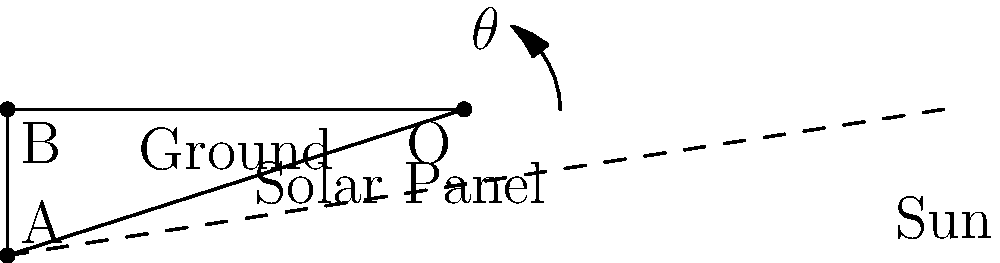In an emergency relief camp, you need to set up solar panels to power essential equipment. The angle of the sun above the horizon is 60°. At what angle $\theta$ should you tilt the solar panels from the ground to maximize energy collection? To maximize energy collection, we want the solar panels to be perpendicular to the incoming sunlight. This means we need to find the angle that makes the solar panel perpendicular to the sun's rays.

Step 1: Recognize that the sun's rays and the ground form a right-angled triangle.
The angle between the sun's rays and the ground is given as 60°.

Step 2: In a right-angled triangle, the sum of all angles is 180°.
$90° + 60° + \theta = 180°$

Step 3: Solve for $\theta$:
$\theta = 180° - 90° - 60°$
$\theta = 30°$

Step 4: Verify the result:
If the solar panel is tilted at 30° from the ground, it will be perpendicular to the sun's rays at 60° above the horizon, forming a right angle (90°) with the sun's rays.

Therefore, to maximize energy collection, the solar panels should be tilted at an angle of 30° from the ground.
Answer: 30° 